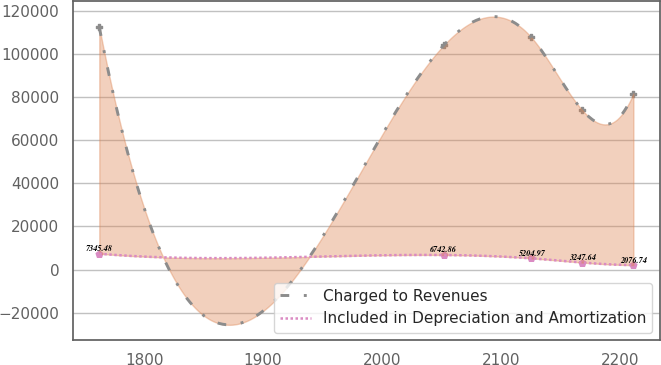Convert chart to OTSL. <chart><loc_0><loc_0><loc_500><loc_500><line_chart><ecel><fcel>Charged to Revenues<fcel>Included in Depreciation and Amortization<nl><fcel>1762.26<fcel>112242<fcel>7345.48<nl><fcel>2051.81<fcel>103872<fcel>6742.86<nl><fcel>2125.38<fcel>107709<fcel>5204.97<nl><fcel>2168.39<fcel>73879.2<fcel>3247.64<nl><fcel>2211.4<fcel>81553.4<fcel>2076.74<nl></chart> 